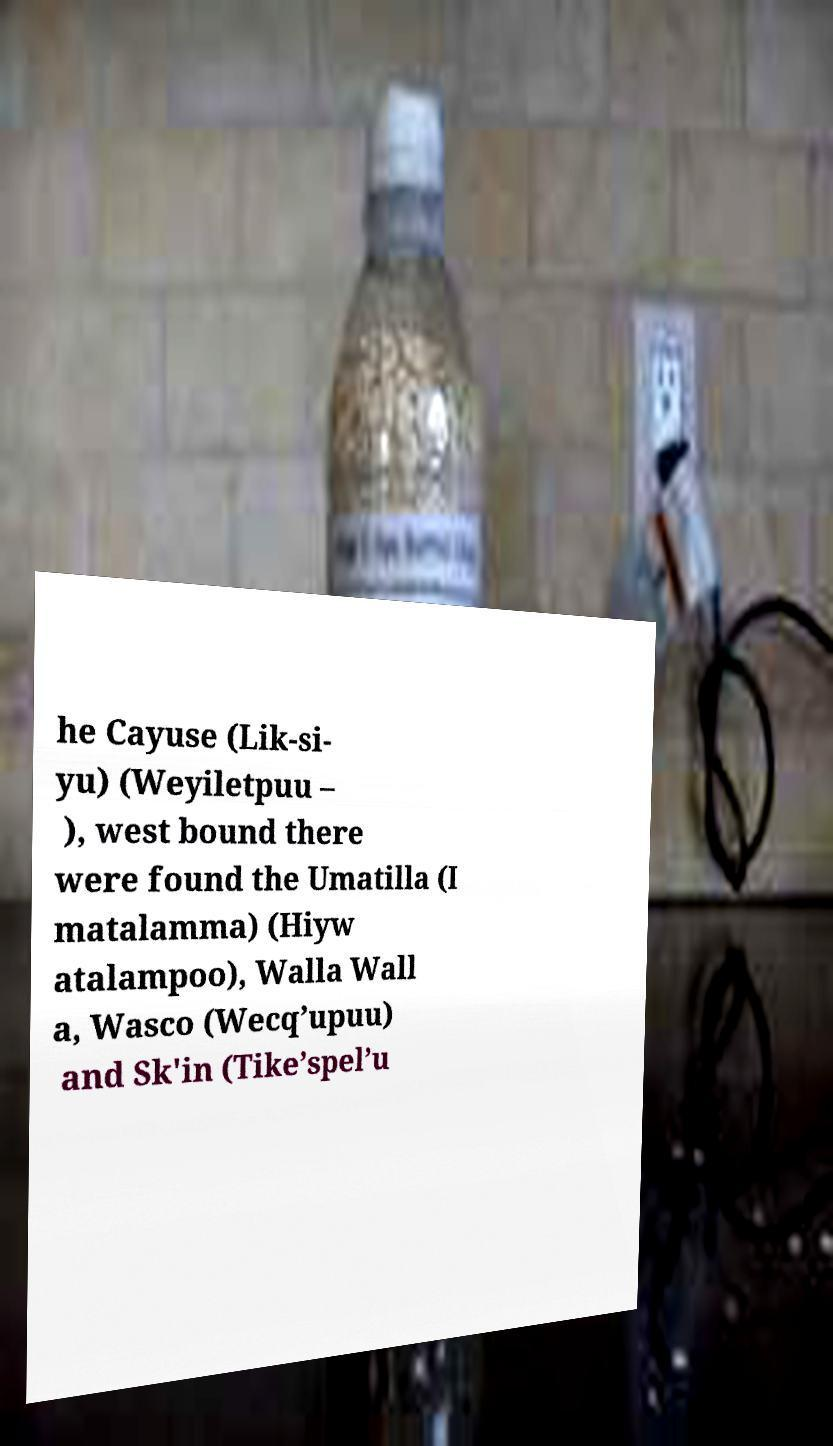Could you extract and type out the text from this image? he Cayuse (Lik-si- yu) (Weyiletpuu – ), west bound there were found the Umatilla (I matalamma) (Hiyw atalampoo), Walla Wall a, Wasco (Wecq’upuu) and Sk'in (Tike’spel’u 